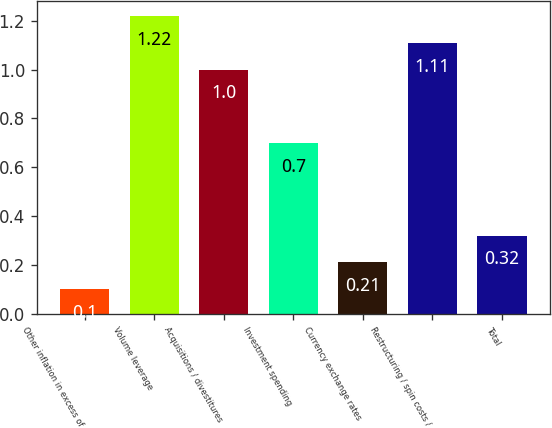Convert chart. <chart><loc_0><loc_0><loc_500><loc_500><bar_chart><fcel>Other inflation in excess of<fcel>Volume leverage<fcel>Acquisitions / divestitures<fcel>Investment spending<fcel>Currency exchange rates<fcel>Restructuring / spin costs /<fcel>Total<nl><fcel>0.1<fcel>1.22<fcel>1<fcel>0.7<fcel>0.21<fcel>1.11<fcel>0.32<nl></chart> 